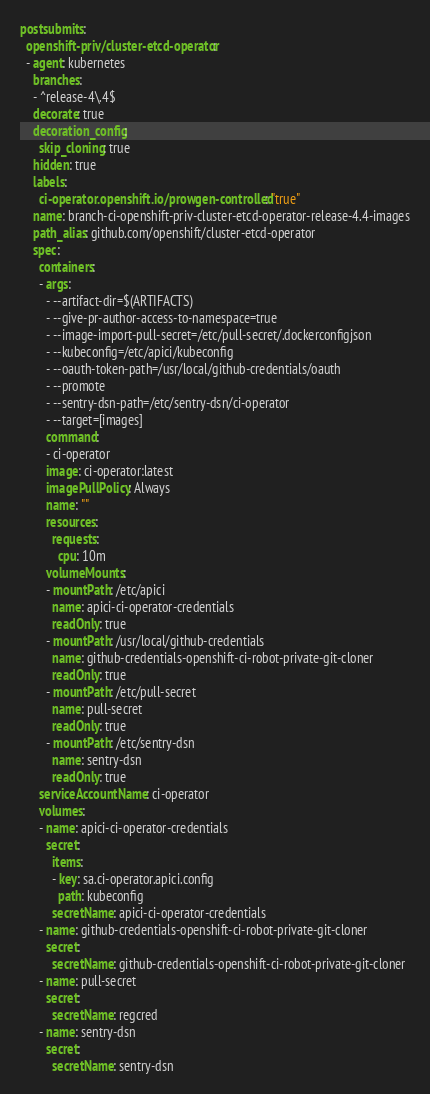Convert code to text. <code><loc_0><loc_0><loc_500><loc_500><_YAML_>postsubmits:
  openshift-priv/cluster-etcd-operator:
  - agent: kubernetes
    branches:
    - ^release-4\.4$
    decorate: true
    decoration_config:
      skip_cloning: true
    hidden: true
    labels:
      ci-operator.openshift.io/prowgen-controlled: "true"
    name: branch-ci-openshift-priv-cluster-etcd-operator-release-4.4-images
    path_alias: github.com/openshift/cluster-etcd-operator
    spec:
      containers:
      - args:
        - --artifact-dir=$(ARTIFACTS)
        - --give-pr-author-access-to-namespace=true
        - --image-import-pull-secret=/etc/pull-secret/.dockerconfigjson
        - --kubeconfig=/etc/apici/kubeconfig
        - --oauth-token-path=/usr/local/github-credentials/oauth
        - --promote
        - --sentry-dsn-path=/etc/sentry-dsn/ci-operator
        - --target=[images]
        command:
        - ci-operator
        image: ci-operator:latest
        imagePullPolicy: Always
        name: ""
        resources:
          requests:
            cpu: 10m
        volumeMounts:
        - mountPath: /etc/apici
          name: apici-ci-operator-credentials
          readOnly: true
        - mountPath: /usr/local/github-credentials
          name: github-credentials-openshift-ci-robot-private-git-cloner
          readOnly: true
        - mountPath: /etc/pull-secret
          name: pull-secret
          readOnly: true
        - mountPath: /etc/sentry-dsn
          name: sentry-dsn
          readOnly: true
      serviceAccountName: ci-operator
      volumes:
      - name: apici-ci-operator-credentials
        secret:
          items:
          - key: sa.ci-operator.apici.config
            path: kubeconfig
          secretName: apici-ci-operator-credentials
      - name: github-credentials-openshift-ci-robot-private-git-cloner
        secret:
          secretName: github-credentials-openshift-ci-robot-private-git-cloner
      - name: pull-secret
        secret:
          secretName: regcred
      - name: sentry-dsn
        secret:
          secretName: sentry-dsn
</code> 